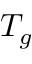<formula> <loc_0><loc_0><loc_500><loc_500>T _ { g }</formula> 